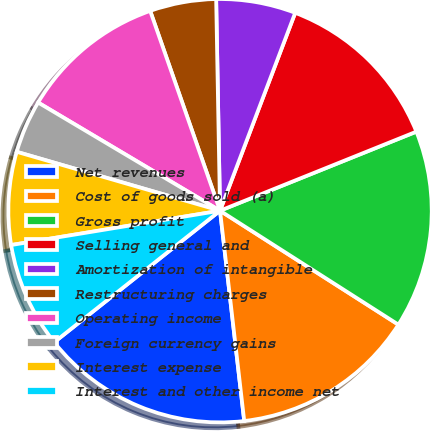Convert chart to OTSL. <chart><loc_0><loc_0><loc_500><loc_500><pie_chart><fcel>Net revenues<fcel>Cost of goods sold (a)<fcel>Gross profit<fcel>Selling general and<fcel>Amortization of intangible<fcel>Restructuring charges<fcel>Operating income<fcel>Foreign currency gains<fcel>Interest expense<fcel>Interest and other income net<nl><fcel>16.15%<fcel>14.13%<fcel>15.14%<fcel>13.13%<fcel>6.07%<fcel>5.06%<fcel>11.11%<fcel>4.05%<fcel>7.08%<fcel>8.08%<nl></chart> 